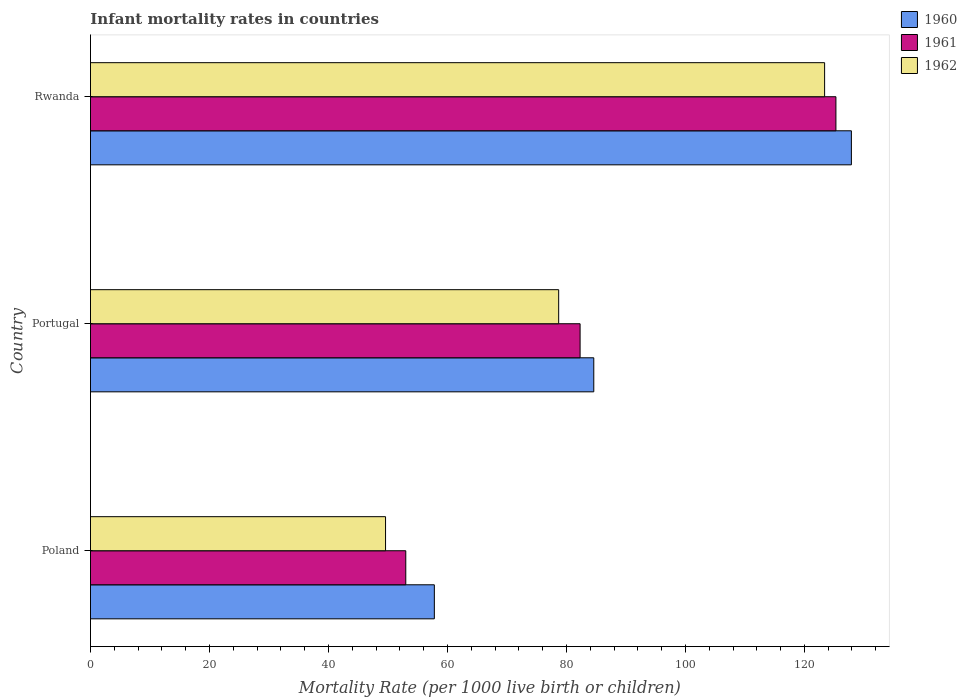How many groups of bars are there?
Give a very brief answer. 3. How many bars are there on the 1st tick from the top?
Offer a very short reply. 3. What is the label of the 1st group of bars from the top?
Make the answer very short. Rwanda. In how many cases, is the number of bars for a given country not equal to the number of legend labels?
Make the answer very short. 0. What is the infant mortality rate in 1962 in Rwanda?
Provide a succinct answer. 123.4. Across all countries, what is the maximum infant mortality rate in 1960?
Your answer should be compact. 127.9. Across all countries, what is the minimum infant mortality rate in 1961?
Give a very brief answer. 53. In which country was the infant mortality rate in 1961 maximum?
Provide a succinct answer. Rwanda. What is the total infant mortality rate in 1962 in the graph?
Give a very brief answer. 251.7. What is the difference between the infant mortality rate in 1962 in Poland and that in Portugal?
Offer a very short reply. -29.1. What is the difference between the infant mortality rate in 1961 in Rwanda and the infant mortality rate in 1962 in Portugal?
Keep it short and to the point. 46.6. What is the average infant mortality rate in 1960 per country?
Provide a succinct answer. 90.1. What is the difference between the infant mortality rate in 1960 and infant mortality rate in 1962 in Portugal?
Your response must be concise. 5.9. In how many countries, is the infant mortality rate in 1961 greater than 120 ?
Ensure brevity in your answer.  1. What is the ratio of the infant mortality rate in 1960 in Poland to that in Portugal?
Keep it short and to the point. 0.68. Is the infant mortality rate in 1961 in Portugal less than that in Rwanda?
Offer a very short reply. Yes. What is the difference between the highest and the second highest infant mortality rate in 1962?
Offer a very short reply. 44.7. What is the difference between the highest and the lowest infant mortality rate in 1960?
Your answer should be very brief. 70.1. What does the 1st bar from the bottom in Poland represents?
Provide a succinct answer. 1960. Is it the case that in every country, the sum of the infant mortality rate in 1960 and infant mortality rate in 1961 is greater than the infant mortality rate in 1962?
Keep it short and to the point. Yes. How many bars are there?
Keep it short and to the point. 9. Are all the bars in the graph horizontal?
Offer a terse response. Yes. What is the difference between two consecutive major ticks on the X-axis?
Make the answer very short. 20. Are the values on the major ticks of X-axis written in scientific E-notation?
Your response must be concise. No. Where does the legend appear in the graph?
Ensure brevity in your answer.  Top right. How many legend labels are there?
Make the answer very short. 3. How are the legend labels stacked?
Make the answer very short. Vertical. What is the title of the graph?
Make the answer very short. Infant mortality rates in countries. What is the label or title of the X-axis?
Give a very brief answer. Mortality Rate (per 1000 live birth or children). What is the Mortality Rate (per 1000 live birth or children) of 1960 in Poland?
Provide a short and direct response. 57.8. What is the Mortality Rate (per 1000 live birth or children) of 1961 in Poland?
Your answer should be compact. 53. What is the Mortality Rate (per 1000 live birth or children) of 1962 in Poland?
Give a very brief answer. 49.6. What is the Mortality Rate (per 1000 live birth or children) of 1960 in Portugal?
Offer a terse response. 84.6. What is the Mortality Rate (per 1000 live birth or children) of 1961 in Portugal?
Offer a very short reply. 82.3. What is the Mortality Rate (per 1000 live birth or children) in 1962 in Portugal?
Give a very brief answer. 78.7. What is the Mortality Rate (per 1000 live birth or children) in 1960 in Rwanda?
Make the answer very short. 127.9. What is the Mortality Rate (per 1000 live birth or children) of 1961 in Rwanda?
Offer a very short reply. 125.3. What is the Mortality Rate (per 1000 live birth or children) in 1962 in Rwanda?
Your answer should be very brief. 123.4. Across all countries, what is the maximum Mortality Rate (per 1000 live birth or children) of 1960?
Offer a terse response. 127.9. Across all countries, what is the maximum Mortality Rate (per 1000 live birth or children) in 1961?
Offer a very short reply. 125.3. Across all countries, what is the maximum Mortality Rate (per 1000 live birth or children) of 1962?
Your answer should be compact. 123.4. Across all countries, what is the minimum Mortality Rate (per 1000 live birth or children) of 1960?
Give a very brief answer. 57.8. Across all countries, what is the minimum Mortality Rate (per 1000 live birth or children) in 1962?
Make the answer very short. 49.6. What is the total Mortality Rate (per 1000 live birth or children) of 1960 in the graph?
Make the answer very short. 270.3. What is the total Mortality Rate (per 1000 live birth or children) in 1961 in the graph?
Make the answer very short. 260.6. What is the total Mortality Rate (per 1000 live birth or children) of 1962 in the graph?
Ensure brevity in your answer.  251.7. What is the difference between the Mortality Rate (per 1000 live birth or children) of 1960 in Poland and that in Portugal?
Provide a succinct answer. -26.8. What is the difference between the Mortality Rate (per 1000 live birth or children) of 1961 in Poland and that in Portugal?
Offer a very short reply. -29.3. What is the difference between the Mortality Rate (per 1000 live birth or children) in 1962 in Poland and that in Portugal?
Provide a short and direct response. -29.1. What is the difference between the Mortality Rate (per 1000 live birth or children) of 1960 in Poland and that in Rwanda?
Ensure brevity in your answer.  -70.1. What is the difference between the Mortality Rate (per 1000 live birth or children) of 1961 in Poland and that in Rwanda?
Ensure brevity in your answer.  -72.3. What is the difference between the Mortality Rate (per 1000 live birth or children) of 1962 in Poland and that in Rwanda?
Keep it short and to the point. -73.8. What is the difference between the Mortality Rate (per 1000 live birth or children) of 1960 in Portugal and that in Rwanda?
Offer a very short reply. -43.3. What is the difference between the Mortality Rate (per 1000 live birth or children) in 1961 in Portugal and that in Rwanda?
Make the answer very short. -43. What is the difference between the Mortality Rate (per 1000 live birth or children) of 1962 in Portugal and that in Rwanda?
Provide a short and direct response. -44.7. What is the difference between the Mortality Rate (per 1000 live birth or children) of 1960 in Poland and the Mortality Rate (per 1000 live birth or children) of 1961 in Portugal?
Your answer should be compact. -24.5. What is the difference between the Mortality Rate (per 1000 live birth or children) of 1960 in Poland and the Mortality Rate (per 1000 live birth or children) of 1962 in Portugal?
Provide a short and direct response. -20.9. What is the difference between the Mortality Rate (per 1000 live birth or children) of 1961 in Poland and the Mortality Rate (per 1000 live birth or children) of 1962 in Portugal?
Keep it short and to the point. -25.7. What is the difference between the Mortality Rate (per 1000 live birth or children) in 1960 in Poland and the Mortality Rate (per 1000 live birth or children) in 1961 in Rwanda?
Keep it short and to the point. -67.5. What is the difference between the Mortality Rate (per 1000 live birth or children) of 1960 in Poland and the Mortality Rate (per 1000 live birth or children) of 1962 in Rwanda?
Give a very brief answer. -65.6. What is the difference between the Mortality Rate (per 1000 live birth or children) in 1961 in Poland and the Mortality Rate (per 1000 live birth or children) in 1962 in Rwanda?
Offer a terse response. -70.4. What is the difference between the Mortality Rate (per 1000 live birth or children) of 1960 in Portugal and the Mortality Rate (per 1000 live birth or children) of 1961 in Rwanda?
Keep it short and to the point. -40.7. What is the difference between the Mortality Rate (per 1000 live birth or children) of 1960 in Portugal and the Mortality Rate (per 1000 live birth or children) of 1962 in Rwanda?
Offer a very short reply. -38.8. What is the difference between the Mortality Rate (per 1000 live birth or children) of 1961 in Portugal and the Mortality Rate (per 1000 live birth or children) of 1962 in Rwanda?
Ensure brevity in your answer.  -41.1. What is the average Mortality Rate (per 1000 live birth or children) in 1960 per country?
Keep it short and to the point. 90.1. What is the average Mortality Rate (per 1000 live birth or children) in 1961 per country?
Your answer should be compact. 86.87. What is the average Mortality Rate (per 1000 live birth or children) in 1962 per country?
Provide a succinct answer. 83.9. What is the difference between the Mortality Rate (per 1000 live birth or children) in 1960 and Mortality Rate (per 1000 live birth or children) in 1961 in Poland?
Provide a short and direct response. 4.8. What is the difference between the Mortality Rate (per 1000 live birth or children) of 1960 and Mortality Rate (per 1000 live birth or children) of 1962 in Poland?
Offer a very short reply. 8.2. What is the difference between the Mortality Rate (per 1000 live birth or children) of 1960 and Mortality Rate (per 1000 live birth or children) of 1962 in Portugal?
Provide a succinct answer. 5.9. What is the ratio of the Mortality Rate (per 1000 live birth or children) of 1960 in Poland to that in Portugal?
Make the answer very short. 0.68. What is the ratio of the Mortality Rate (per 1000 live birth or children) of 1961 in Poland to that in Portugal?
Your answer should be very brief. 0.64. What is the ratio of the Mortality Rate (per 1000 live birth or children) of 1962 in Poland to that in Portugal?
Ensure brevity in your answer.  0.63. What is the ratio of the Mortality Rate (per 1000 live birth or children) in 1960 in Poland to that in Rwanda?
Offer a very short reply. 0.45. What is the ratio of the Mortality Rate (per 1000 live birth or children) of 1961 in Poland to that in Rwanda?
Offer a very short reply. 0.42. What is the ratio of the Mortality Rate (per 1000 live birth or children) of 1962 in Poland to that in Rwanda?
Your answer should be compact. 0.4. What is the ratio of the Mortality Rate (per 1000 live birth or children) of 1960 in Portugal to that in Rwanda?
Provide a short and direct response. 0.66. What is the ratio of the Mortality Rate (per 1000 live birth or children) in 1961 in Portugal to that in Rwanda?
Keep it short and to the point. 0.66. What is the ratio of the Mortality Rate (per 1000 live birth or children) in 1962 in Portugal to that in Rwanda?
Offer a terse response. 0.64. What is the difference between the highest and the second highest Mortality Rate (per 1000 live birth or children) of 1960?
Your response must be concise. 43.3. What is the difference between the highest and the second highest Mortality Rate (per 1000 live birth or children) in 1961?
Offer a very short reply. 43. What is the difference between the highest and the second highest Mortality Rate (per 1000 live birth or children) in 1962?
Your response must be concise. 44.7. What is the difference between the highest and the lowest Mortality Rate (per 1000 live birth or children) of 1960?
Your answer should be compact. 70.1. What is the difference between the highest and the lowest Mortality Rate (per 1000 live birth or children) of 1961?
Provide a succinct answer. 72.3. What is the difference between the highest and the lowest Mortality Rate (per 1000 live birth or children) of 1962?
Provide a succinct answer. 73.8. 